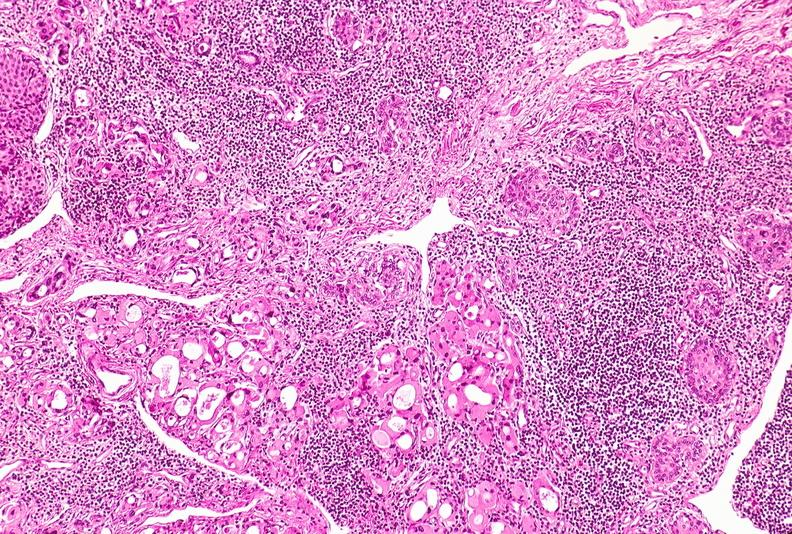does this image show thyroid, hashimoto 's?
Answer the question using a single word or phrase. Yes 